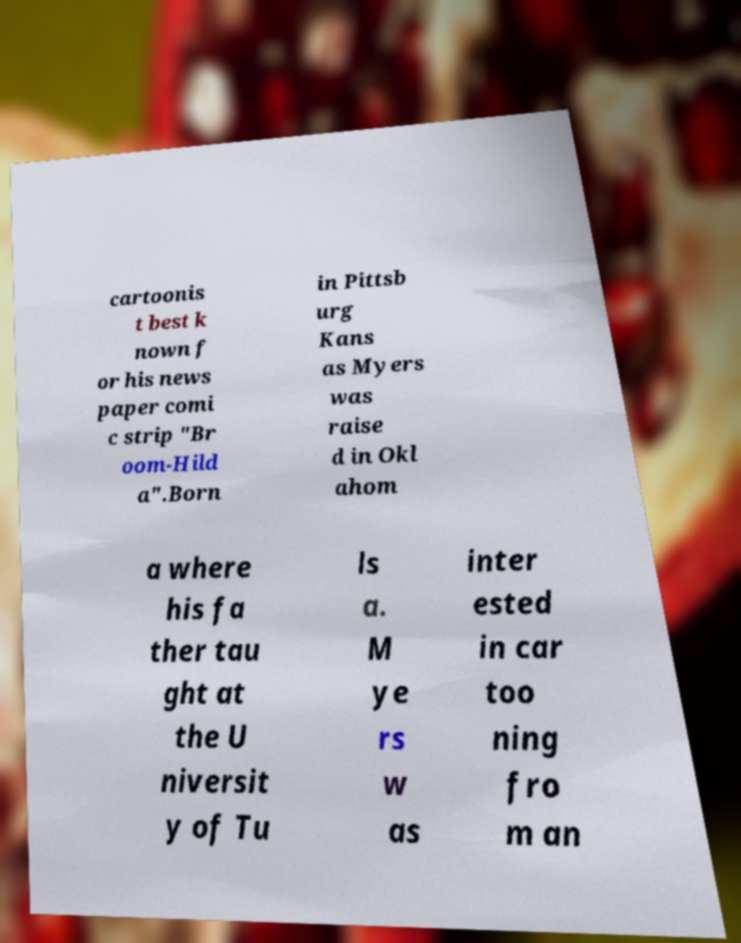Can you accurately transcribe the text from the provided image for me? cartoonis t best k nown f or his news paper comi c strip "Br oom-Hild a".Born in Pittsb urg Kans as Myers was raise d in Okl ahom a where his fa ther tau ght at the U niversit y of Tu ls a. M ye rs w as inter ested in car too ning fro m an 